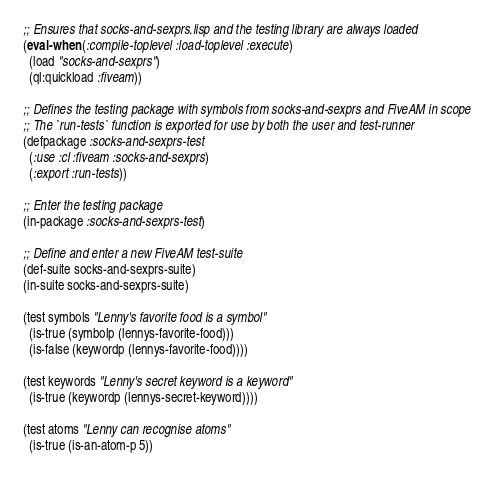Convert code to text. <code><loc_0><loc_0><loc_500><loc_500><_Lisp_>;; Ensures that socks-and-sexprs.lisp and the testing library are always loaded
(eval-when (:compile-toplevel :load-toplevel :execute)
  (load "socks-and-sexprs")
  (ql:quickload :fiveam))

;; Defines the testing package with symbols from socks-and-sexprs and FiveAM in scope
;; The `run-tests` function is exported for use by both the user and test-runner
(defpackage :socks-and-sexprs-test
  (:use :cl :fiveam :socks-and-sexprs)
  (:export :run-tests))

;; Enter the testing package
(in-package :socks-and-sexprs-test)

;; Define and enter a new FiveAM test-suite
(def-suite socks-and-sexprs-suite)
(in-suite socks-and-sexprs-suite)

(test symbols "Lenny's favorite food is a symbol"
  (is-true (symbolp (lennys-favorite-food)))
  (is-false (keywordp (lennys-favorite-food))))

(test keywords "Lenny's secret keyword is a keyword"
  (is-true (keywordp (lennys-secret-keyword))))

(test atoms "Lenny can recognise atoms"
  (is-true (is-an-atom-p 5))</code> 